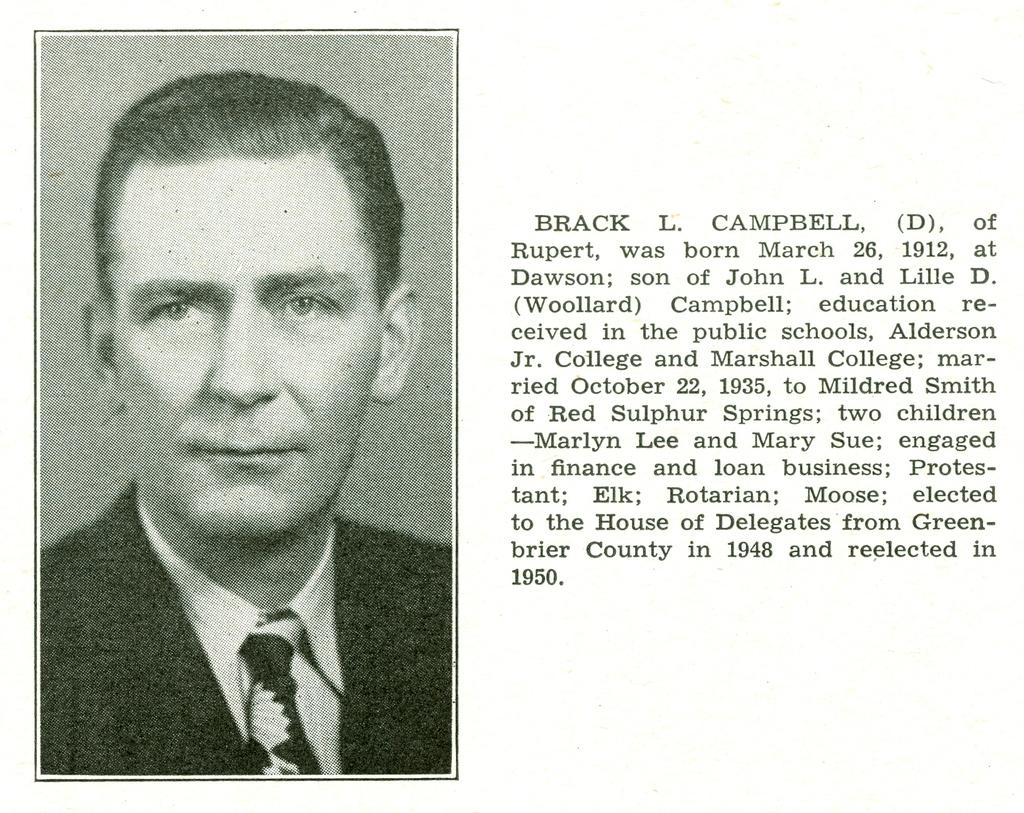What is the main subject of the image? The main subject of the image is a man's photograph. Where is the photograph located in the image? The photograph is on the left side of the image. What else can be seen in the image besides the photograph? There is text visible in the image. Where is the text located in the image? The text is on the right side of the image. What type of clouds can be seen in the photograph? There are no clouds visible in the photograph, as it is a photograph of a man. 